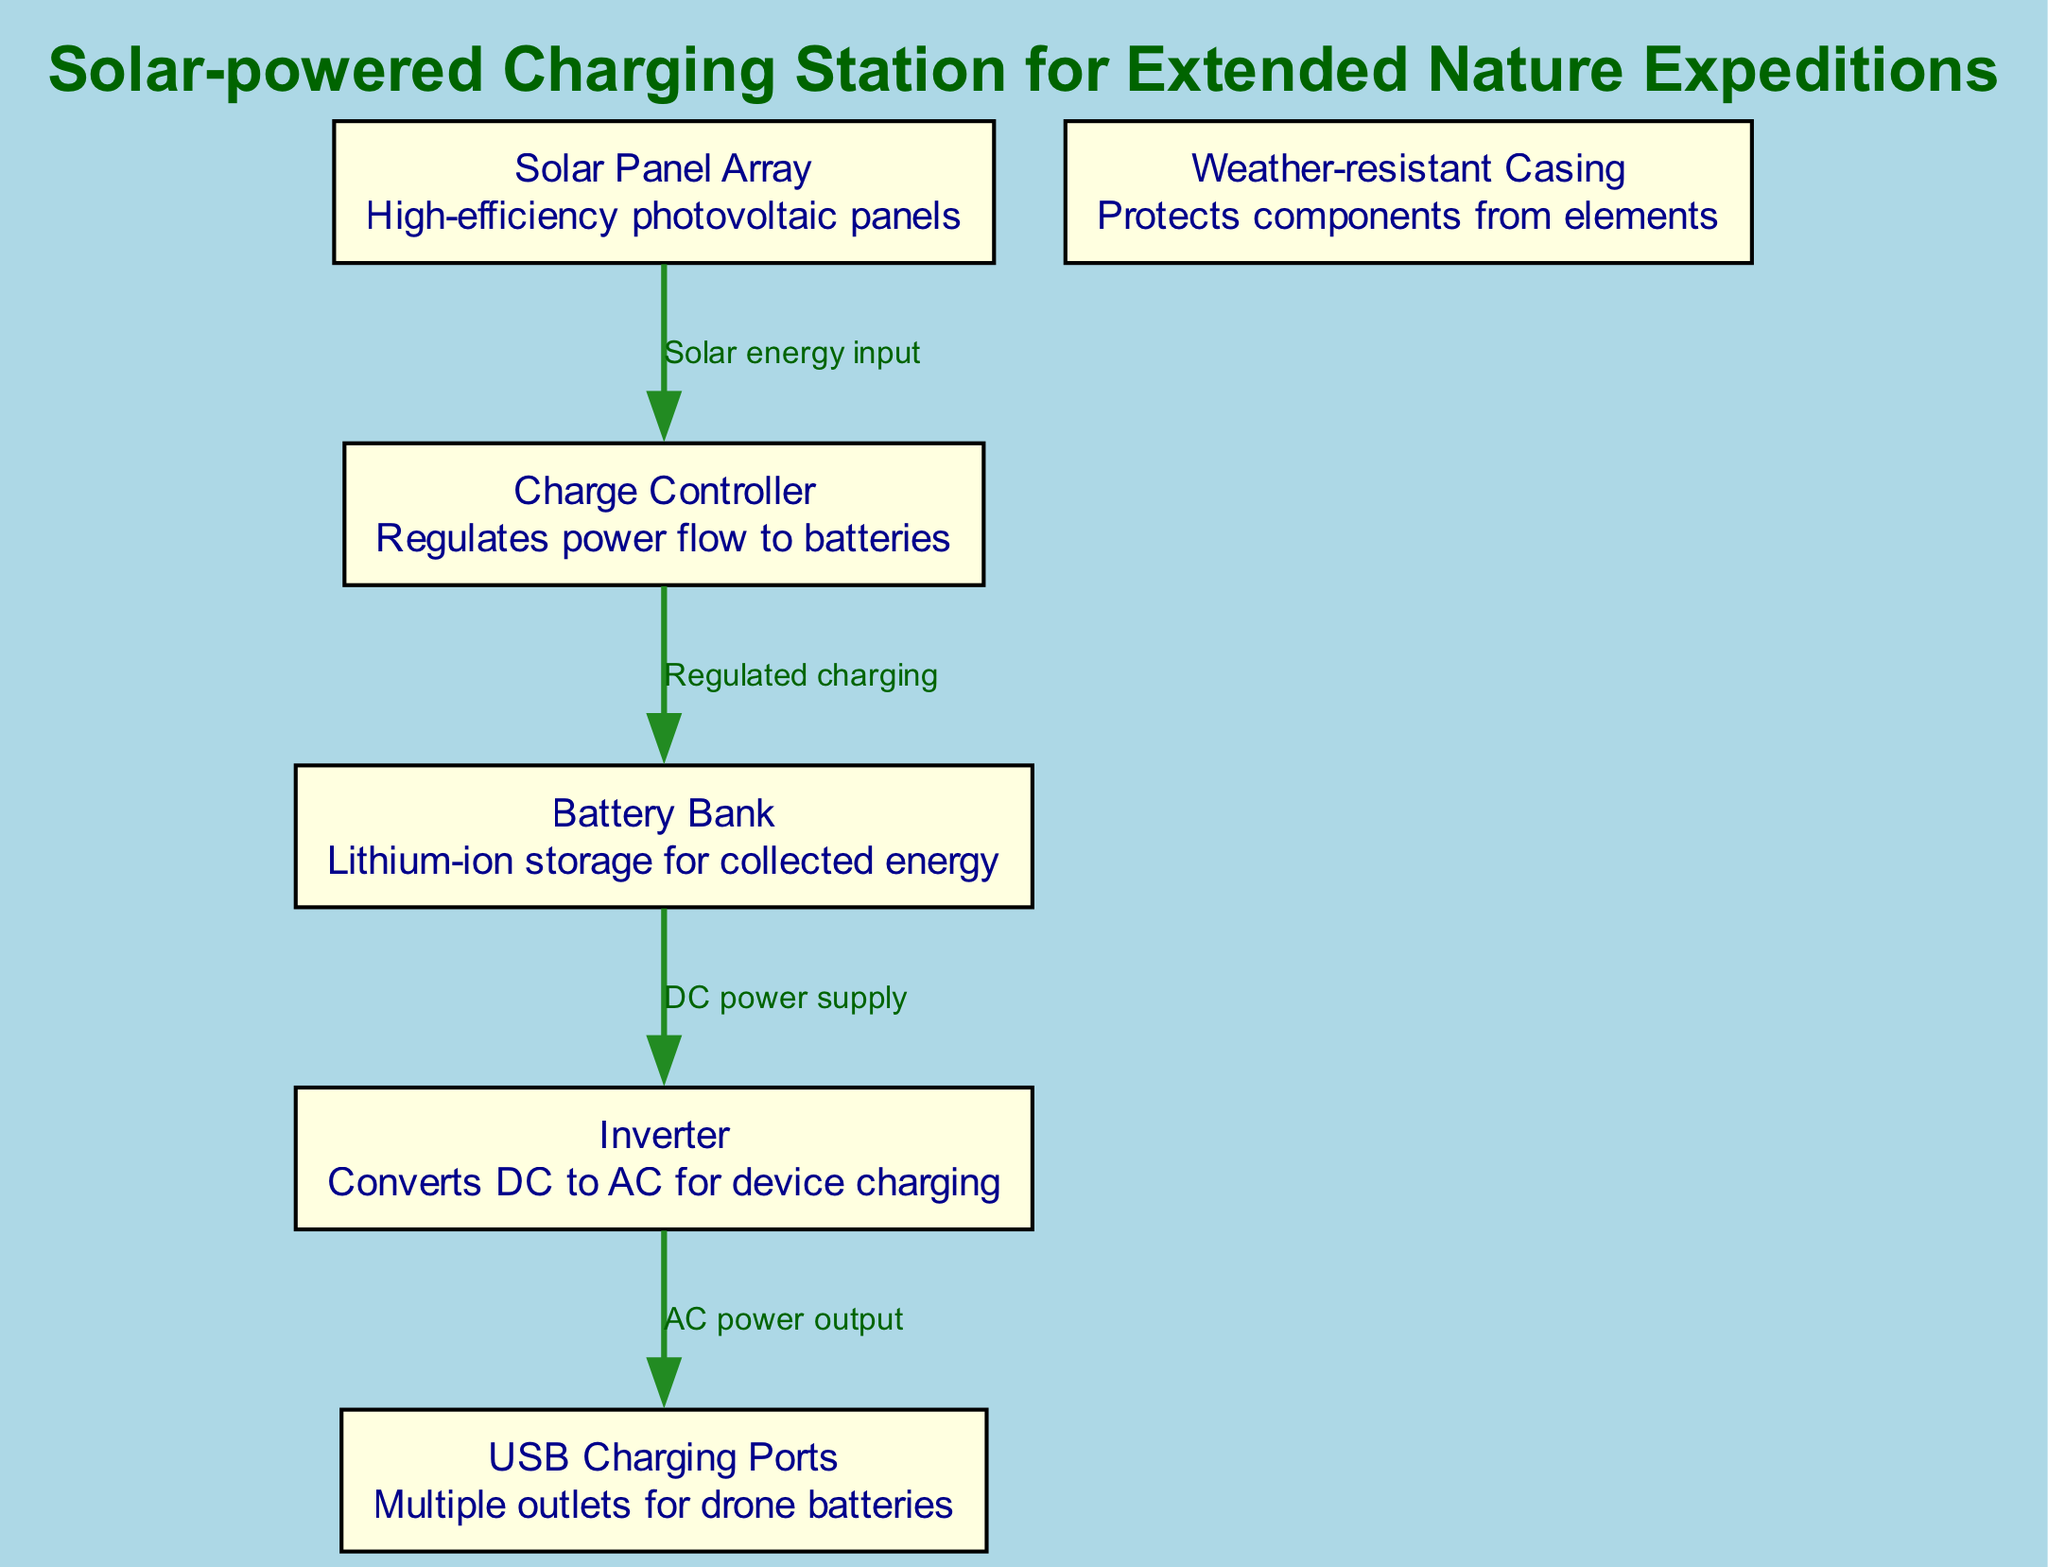What is the function of the Charge Controller? The Charge Controller regulates power flow to the batteries, ensuring that they are charged efficiently and safely. This is a crucial step since it prevents overcharging, which could damage the batteries.
Answer: Regulates power flow How many nodes are in the diagram? The diagram contains six nodes. Each node represents a different component of the solar-powered charging station. These are the Solar Panel Array, Battery Bank, Charge Controller, Inverter, USB Charging Ports, and Weather-resistant Casing.
Answer: Six What is the edge label between the Solar Panel Array and the Charge Controller? The edge label indicates the relationship, which is "Solar energy input." This means that the solar panel array sends collected solar energy to the charge controller for regulation.
Answer: Solar energy input What type of energy does the Inverter convert? The Inverter converts direct current (DC) power from the Battery Bank into alternating current (AC), making it suitable for charging devices that require AC power.
Answer: DC to AC What protects the components from the elements? The Weather-resistant Casing is designed to protect all the components of the charging station from various environmental factors such as rain, dust, and extreme temperatures.
Answer: Weather-resistant Casing What is the relationship between the Battery Bank and the Inverter? The relationship is marked by "DC power supply," indicating that the Battery Bank supplies direct current to the Inverter for conversion to alternating current for output.
Answer: DC power supply 